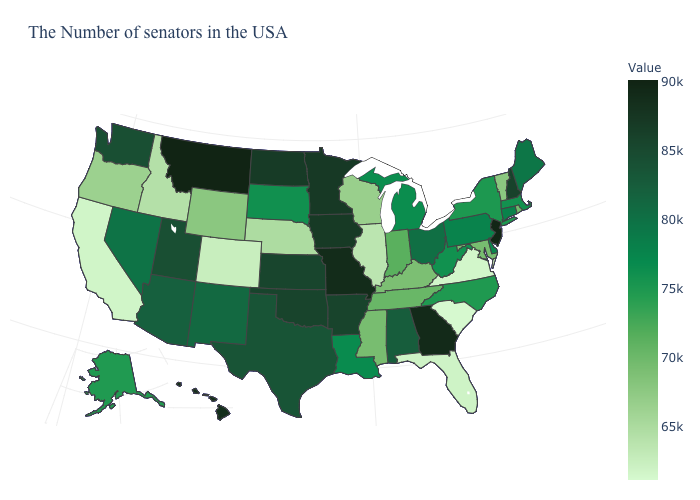Among the states that border Florida , which have the lowest value?
Short answer required. Alabama. Is the legend a continuous bar?
Keep it brief. Yes. Among the states that border Washington , which have the highest value?
Answer briefly. Oregon. Is the legend a continuous bar?
Be succinct. Yes. Among the states that border California , does Oregon have the lowest value?
Be succinct. Yes. 